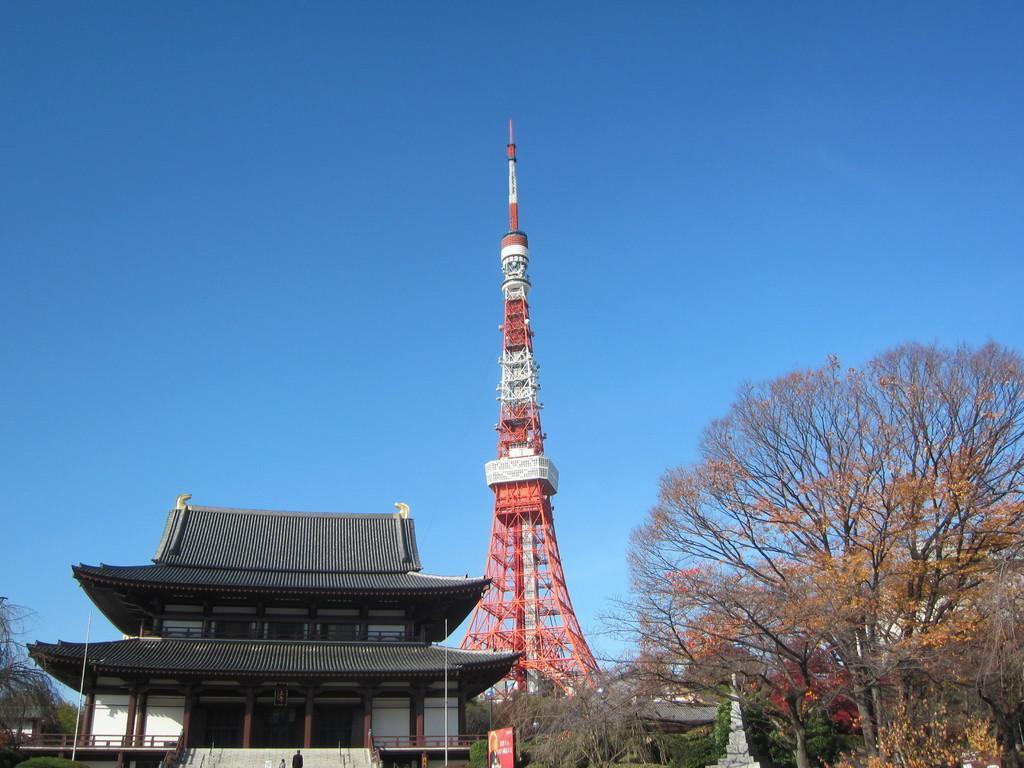Could you give a brief overview of what you see in this image? In this image I can see the house and the tower. The house is in grey color and the tower is in red and white color. I can see many trees to the side. In the background I can see the blue sky. 